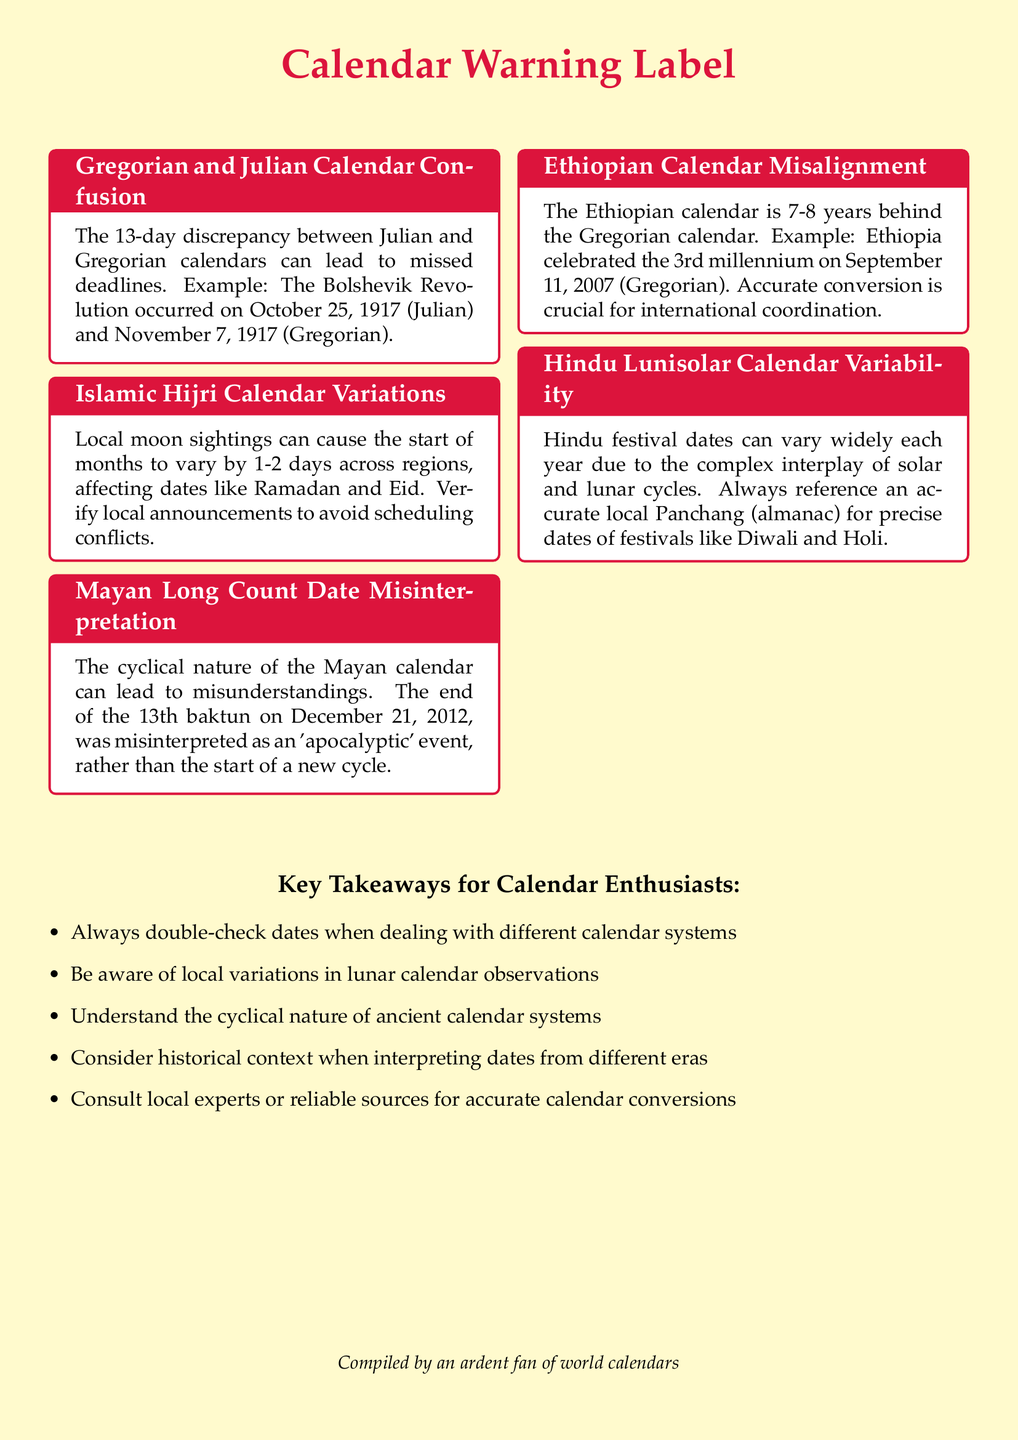What is the discrepancy in days between the Julian and Gregorian calendars? The document states that there is a 13-day discrepancy between the Julian and Gregorian calendars.
Answer: 13 days What important event is noted in the Gregorian calendar in relation to the Bolshevik Revolution? The document specifies that the Bolshevik Revolution occurred on November 7, 1917, in the Gregorian calendar.
Answer: November 7, 1917 How many days can the start of months vary by in the Islamic Hijri calendar? The text mentions that the start of months can vary by 1-2 days across regions in the Islamic Hijri calendar.
Answer: 1-2 days By how many years is the Ethiopian calendar behind the Gregorian calendar? The document notes the Ethiopian calendar is 7-8 years behind the Gregorian calendar.
Answer: 7-8 years Which significant date did Ethiopia celebrate according to the Gregorian calendar? The document states that Ethiopia celebrated the 3rd millennium on September 11, 2007, in the Gregorian calendar.
Answer: September 11, 2007 What should one always reference for precise Hindu festival dates? It is advised in the document to reference an accurate local Panchang (almanac) for Hindu festival dates.
Answer: Accurate local Panchang What phenomenon caused misunderstandings about the Mayan Long Count calendar? The document highlights that the cyclical nature of the Mayan calendar led to misunderstandings regarding the end of the 13th baktun.
Answer: Cyclical nature What is emphasized for accurate coordination in the Ethiopian calendar section? The document emphasizes that accurate conversion is crucial for international coordination concerning the Ethiopian calendar.
Answer: Accurate conversion What must you always do when dealing with different calendar systems? The document advises to always double-check dates when dealing with different calendar systems.
Answer: Double-check dates 